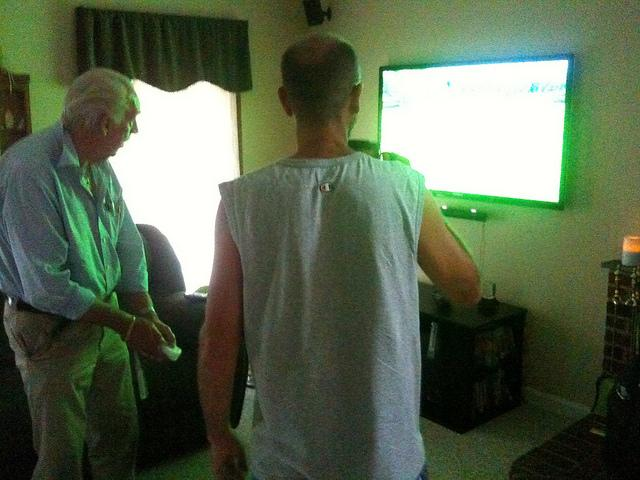Which sport is the man on the left most likely playing on the nintendo wii appliance? Please explain your reasoning. golf. The man is holding his control down as if putting. 